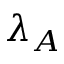<formula> <loc_0><loc_0><loc_500><loc_500>\lambda _ { A }</formula> 